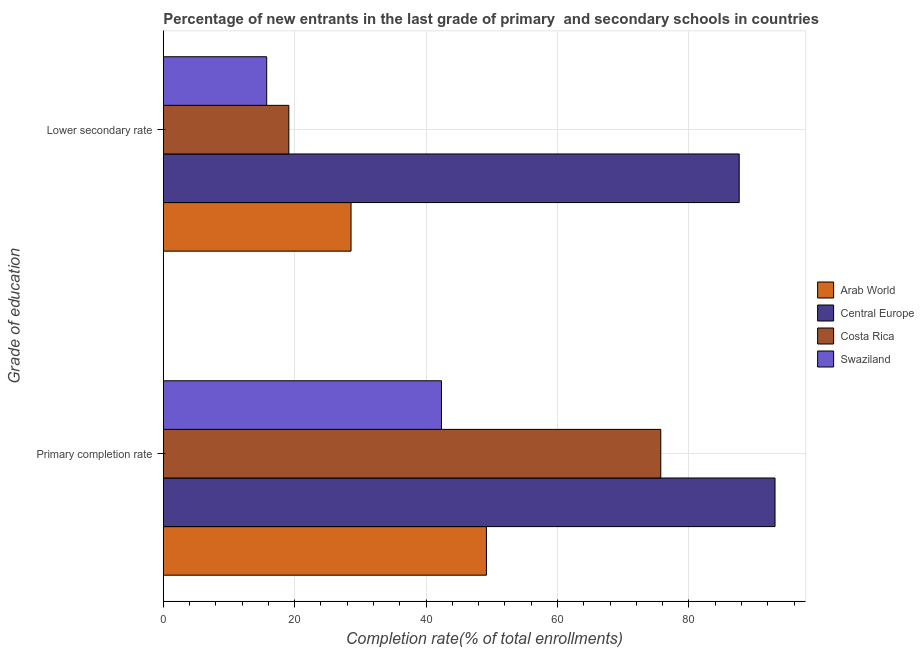How many groups of bars are there?
Keep it short and to the point. 2. Are the number of bars on each tick of the Y-axis equal?
Offer a very short reply. Yes. How many bars are there on the 1st tick from the top?
Provide a short and direct response. 4. How many bars are there on the 2nd tick from the bottom?
Your answer should be compact. 4. What is the label of the 2nd group of bars from the top?
Keep it short and to the point. Primary completion rate. What is the completion rate in secondary schools in Central Europe?
Provide a short and direct response. 87.65. Across all countries, what is the maximum completion rate in secondary schools?
Give a very brief answer. 87.65. Across all countries, what is the minimum completion rate in secondary schools?
Ensure brevity in your answer.  15.74. In which country was the completion rate in secondary schools maximum?
Offer a very short reply. Central Europe. In which country was the completion rate in secondary schools minimum?
Provide a short and direct response. Swaziland. What is the total completion rate in secondary schools in the graph?
Provide a succinct answer. 151.08. What is the difference between the completion rate in primary schools in Swaziland and that in Central Europe?
Keep it short and to the point. -50.76. What is the difference between the completion rate in primary schools in Swaziland and the completion rate in secondary schools in Costa Rica?
Offer a terse response. 23.23. What is the average completion rate in primary schools per country?
Provide a succinct answer. 65.08. What is the difference between the completion rate in primary schools and completion rate in secondary schools in Costa Rica?
Provide a succinct answer. 56.61. In how many countries, is the completion rate in primary schools greater than 32 %?
Provide a succinct answer. 4. What is the ratio of the completion rate in primary schools in Arab World to that in Central Europe?
Provide a succinct answer. 0.53. In how many countries, is the completion rate in secondary schools greater than the average completion rate in secondary schools taken over all countries?
Offer a very short reply. 1. What does the 3rd bar from the bottom in Lower secondary rate represents?
Keep it short and to the point. Costa Rica. How many bars are there?
Your answer should be very brief. 8. How many countries are there in the graph?
Keep it short and to the point. 4. Does the graph contain any zero values?
Offer a very short reply. No. How many legend labels are there?
Make the answer very short. 4. How are the legend labels stacked?
Make the answer very short. Vertical. What is the title of the graph?
Your answer should be very brief. Percentage of new entrants in the last grade of primary  and secondary schools in countries. Does "Australia" appear as one of the legend labels in the graph?
Provide a succinct answer. No. What is the label or title of the X-axis?
Keep it short and to the point. Completion rate(% of total enrollments). What is the label or title of the Y-axis?
Give a very brief answer. Grade of education. What is the Completion rate(% of total enrollments) of Arab World in Primary completion rate?
Keep it short and to the point. 49.18. What is the Completion rate(% of total enrollments) of Central Europe in Primary completion rate?
Your answer should be very brief. 93.1. What is the Completion rate(% of total enrollments) in Costa Rica in Primary completion rate?
Provide a succinct answer. 75.71. What is the Completion rate(% of total enrollments) in Swaziland in Primary completion rate?
Provide a succinct answer. 42.34. What is the Completion rate(% of total enrollments) in Arab World in Lower secondary rate?
Provide a short and direct response. 28.58. What is the Completion rate(% of total enrollments) in Central Europe in Lower secondary rate?
Offer a terse response. 87.65. What is the Completion rate(% of total enrollments) in Costa Rica in Lower secondary rate?
Ensure brevity in your answer.  19.11. What is the Completion rate(% of total enrollments) of Swaziland in Lower secondary rate?
Give a very brief answer. 15.74. Across all Grade of education, what is the maximum Completion rate(% of total enrollments) in Arab World?
Offer a terse response. 49.18. Across all Grade of education, what is the maximum Completion rate(% of total enrollments) in Central Europe?
Ensure brevity in your answer.  93.1. Across all Grade of education, what is the maximum Completion rate(% of total enrollments) in Costa Rica?
Ensure brevity in your answer.  75.71. Across all Grade of education, what is the maximum Completion rate(% of total enrollments) of Swaziland?
Your answer should be very brief. 42.34. Across all Grade of education, what is the minimum Completion rate(% of total enrollments) in Arab World?
Your answer should be very brief. 28.58. Across all Grade of education, what is the minimum Completion rate(% of total enrollments) in Central Europe?
Ensure brevity in your answer.  87.65. Across all Grade of education, what is the minimum Completion rate(% of total enrollments) of Costa Rica?
Your response must be concise. 19.11. Across all Grade of education, what is the minimum Completion rate(% of total enrollments) of Swaziland?
Your response must be concise. 15.74. What is the total Completion rate(% of total enrollments) of Arab World in the graph?
Offer a terse response. 77.76. What is the total Completion rate(% of total enrollments) in Central Europe in the graph?
Ensure brevity in your answer.  180.75. What is the total Completion rate(% of total enrollments) in Costa Rica in the graph?
Provide a succinct answer. 94.82. What is the total Completion rate(% of total enrollments) in Swaziland in the graph?
Keep it short and to the point. 58.08. What is the difference between the Completion rate(% of total enrollments) in Arab World in Primary completion rate and that in Lower secondary rate?
Your answer should be very brief. 20.6. What is the difference between the Completion rate(% of total enrollments) of Central Europe in Primary completion rate and that in Lower secondary rate?
Make the answer very short. 5.45. What is the difference between the Completion rate(% of total enrollments) of Costa Rica in Primary completion rate and that in Lower secondary rate?
Your answer should be compact. 56.61. What is the difference between the Completion rate(% of total enrollments) in Swaziland in Primary completion rate and that in Lower secondary rate?
Keep it short and to the point. 26.6. What is the difference between the Completion rate(% of total enrollments) of Arab World in Primary completion rate and the Completion rate(% of total enrollments) of Central Europe in Lower secondary rate?
Your answer should be very brief. -38.47. What is the difference between the Completion rate(% of total enrollments) of Arab World in Primary completion rate and the Completion rate(% of total enrollments) of Costa Rica in Lower secondary rate?
Your answer should be compact. 30.07. What is the difference between the Completion rate(% of total enrollments) of Arab World in Primary completion rate and the Completion rate(% of total enrollments) of Swaziland in Lower secondary rate?
Offer a very short reply. 33.44. What is the difference between the Completion rate(% of total enrollments) of Central Europe in Primary completion rate and the Completion rate(% of total enrollments) of Costa Rica in Lower secondary rate?
Provide a succinct answer. 74. What is the difference between the Completion rate(% of total enrollments) in Central Europe in Primary completion rate and the Completion rate(% of total enrollments) in Swaziland in Lower secondary rate?
Offer a very short reply. 77.36. What is the difference between the Completion rate(% of total enrollments) in Costa Rica in Primary completion rate and the Completion rate(% of total enrollments) in Swaziland in Lower secondary rate?
Your response must be concise. 59.98. What is the average Completion rate(% of total enrollments) in Arab World per Grade of education?
Offer a very short reply. 38.88. What is the average Completion rate(% of total enrollments) of Central Europe per Grade of education?
Your response must be concise. 90.38. What is the average Completion rate(% of total enrollments) of Costa Rica per Grade of education?
Provide a succinct answer. 47.41. What is the average Completion rate(% of total enrollments) in Swaziland per Grade of education?
Provide a short and direct response. 29.04. What is the difference between the Completion rate(% of total enrollments) in Arab World and Completion rate(% of total enrollments) in Central Europe in Primary completion rate?
Your answer should be very brief. -43.92. What is the difference between the Completion rate(% of total enrollments) of Arab World and Completion rate(% of total enrollments) of Costa Rica in Primary completion rate?
Keep it short and to the point. -26.54. What is the difference between the Completion rate(% of total enrollments) of Arab World and Completion rate(% of total enrollments) of Swaziland in Primary completion rate?
Offer a terse response. 6.84. What is the difference between the Completion rate(% of total enrollments) of Central Europe and Completion rate(% of total enrollments) of Costa Rica in Primary completion rate?
Your answer should be very brief. 17.39. What is the difference between the Completion rate(% of total enrollments) of Central Europe and Completion rate(% of total enrollments) of Swaziland in Primary completion rate?
Your response must be concise. 50.76. What is the difference between the Completion rate(% of total enrollments) of Costa Rica and Completion rate(% of total enrollments) of Swaziland in Primary completion rate?
Provide a succinct answer. 33.38. What is the difference between the Completion rate(% of total enrollments) in Arab World and Completion rate(% of total enrollments) in Central Europe in Lower secondary rate?
Your answer should be very brief. -59.08. What is the difference between the Completion rate(% of total enrollments) in Arab World and Completion rate(% of total enrollments) in Costa Rica in Lower secondary rate?
Offer a very short reply. 9.47. What is the difference between the Completion rate(% of total enrollments) of Arab World and Completion rate(% of total enrollments) of Swaziland in Lower secondary rate?
Provide a short and direct response. 12.84. What is the difference between the Completion rate(% of total enrollments) of Central Europe and Completion rate(% of total enrollments) of Costa Rica in Lower secondary rate?
Keep it short and to the point. 68.54. What is the difference between the Completion rate(% of total enrollments) of Central Europe and Completion rate(% of total enrollments) of Swaziland in Lower secondary rate?
Your answer should be very brief. 71.91. What is the difference between the Completion rate(% of total enrollments) in Costa Rica and Completion rate(% of total enrollments) in Swaziland in Lower secondary rate?
Provide a succinct answer. 3.37. What is the ratio of the Completion rate(% of total enrollments) in Arab World in Primary completion rate to that in Lower secondary rate?
Provide a short and direct response. 1.72. What is the ratio of the Completion rate(% of total enrollments) of Central Europe in Primary completion rate to that in Lower secondary rate?
Offer a terse response. 1.06. What is the ratio of the Completion rate(% of total enrollments) in Costa Rica in Primary completion rate to that in Lower secondary rate?
Your answer should be very brief. 3.96. What is the ratio of the Completion rate(% of total enrollments) in Swaziland in Primary completion rate to that in Lower secondary rate?
Provide a succinct answer. 2.69. What is the difference between the highest and the second highest Completion rate(% of total enrollments) of Arab World?
Provide a succinct answer. 20.6. What is the difference between the highest and the second highest Completion rate(% of total enrollments) of Central Europe?
Provide a succinct answer. 5.45. What is the difference between the highest and the second highest Completion rate(% of total enrollments) in Costa Rica?
Make the answer very short. 56.61. What is the difference between the highest and the second highest Completion rate(% of total enrollments) of Swaziland?
Your answer should be compact. 26.6. What is the difference between the highest and the lowest Completion rate(% of total enrollments) in Arab World?
Your answer should be compact. 20.6. What is the difference between the highest and the lowest Completion rate(% of total enrollments) of Central Europe?
Provide a succinct answer. 5.45. What is the difference between the highest and the lowest Completion rate(% of total enrollments) of Costa Rica?
Make the answer very short. 56.61. What is the difference between the highest and the lowest Completion rate(% of total enrollments) in Swaziland?
Provide a succinct answer. 26.6. 